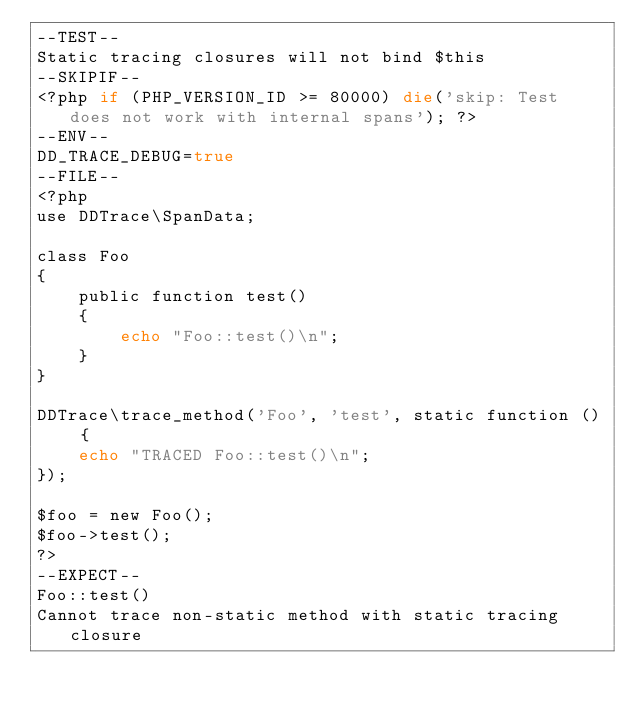Convert code to text. <code><loc_0><loc_0><loc_500><loc_500><_PHP_>--TEST--
Static tracing closures will not bind $this
--SKIPIF--
<?php if (PHP_VERSION_ID >= 80000) die('skip: Test does not work with internal spans'); ?>
--ENV--
DD_TRACE_DEBUG=true
--FILE--
<?php
use DDTrace\SpanData;

class Foo
{
    public function test()
    {
        echo "Foo::test()\n";
    }
}

DDTrace\trace_method('Foo', 'test', static function () {
    echo "TRACED Foo::test()\n";
});

$foo = new Foo();
$foo->test();
?>
--EXPECT--
Foo::test()
Cannot trace non-static method with static tracing closure
</code> 